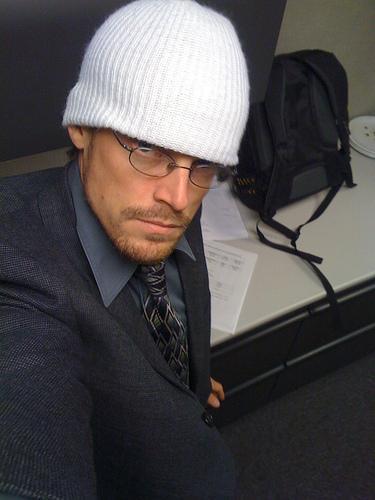How many ties are there?
Give a very brief answer. 1. 